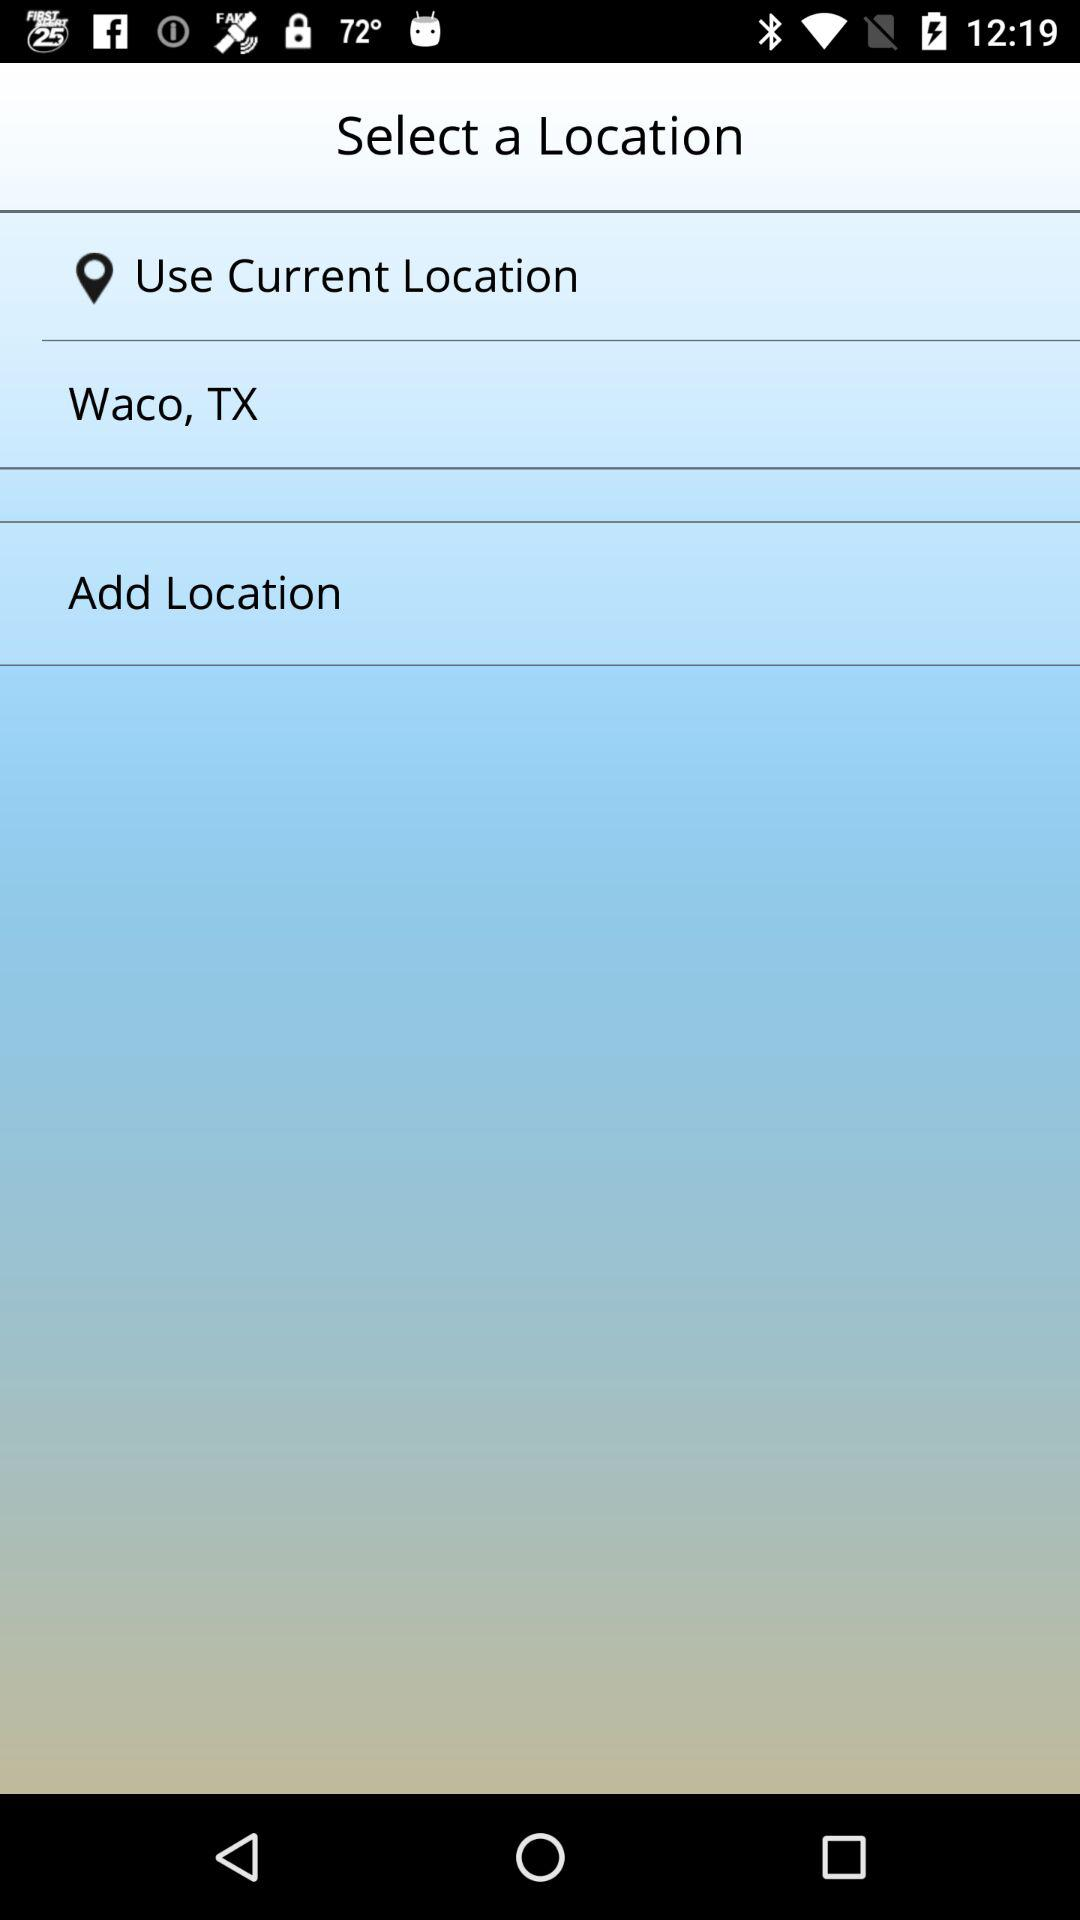What is the current location? The current location is Waco, TX. 